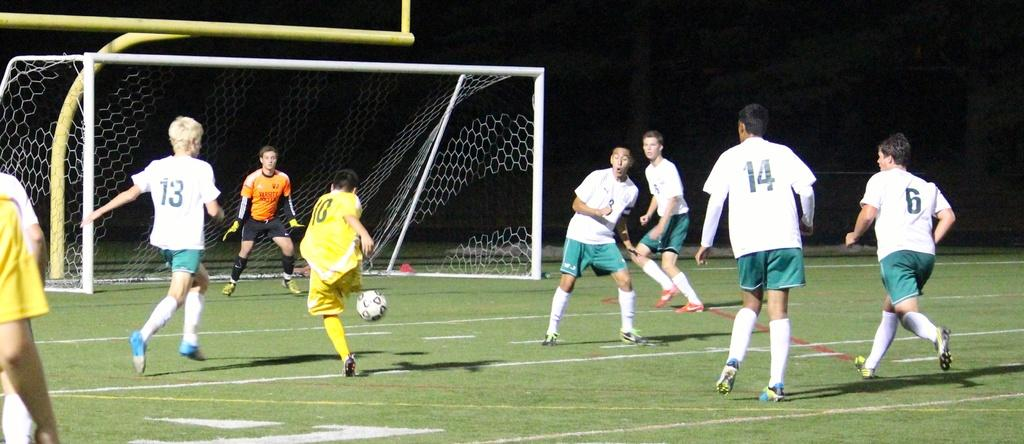What type of activity is being depicted in the image? The image features players, a ball, and a net, suggesting a sports activity. Can you describe the clothing of one of the players? One player is wearing a yellow shirt. What color is the shirt of another player? Another player is wearing an orange shirt. What is the purpose of the net in the image? The net is likely used to divide the playing area or to score points in the game. What is the color of the ground in the image? The ground is green. Where is the bed located in the image? There is no bed present in the image. How many recesses are visible in the image? There is no mention of recesses in the image; it features players, a ball, and a net. 